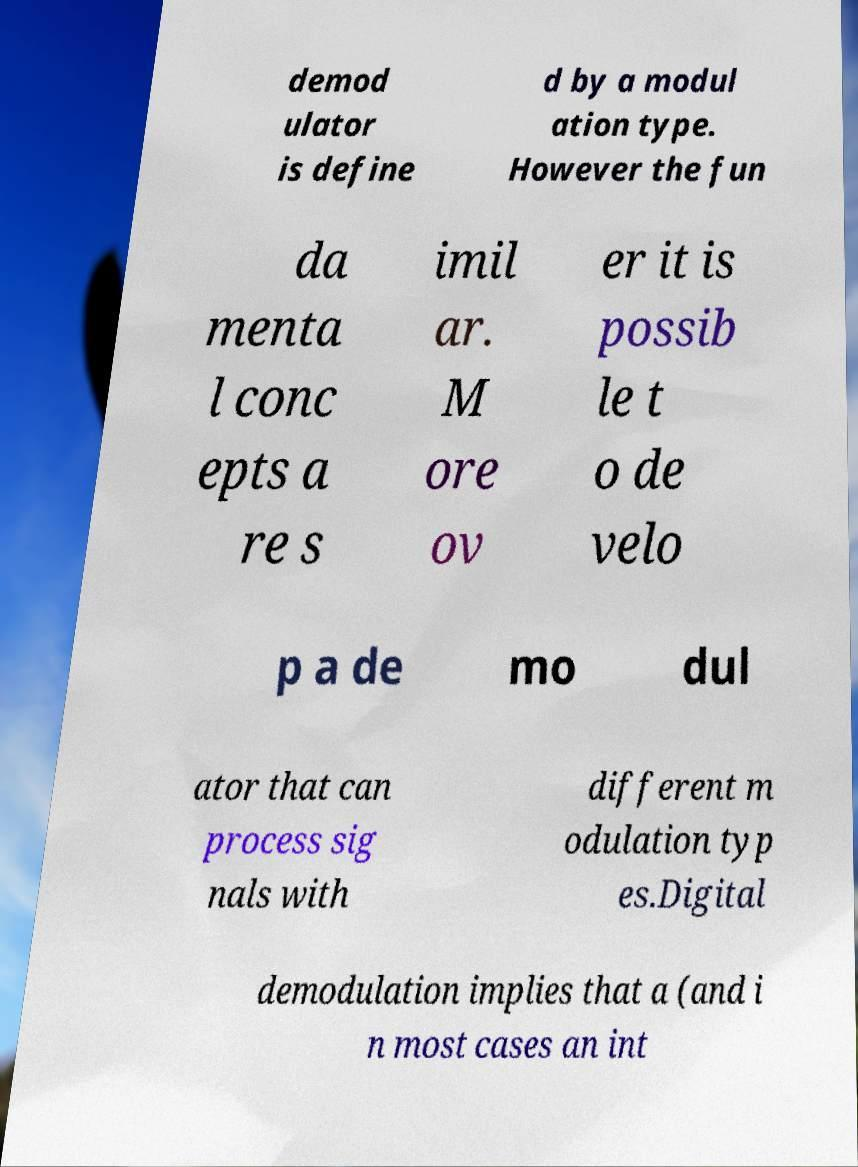There's text embedded in this image that I need extracted. Can you transcribe it verbatim? demod ulator is define d by a modul ation type. However the fun da menta l conc epts a re s imil ar. M ore ov er it is possib le t o de velo p a de mo dul ator that can process sig nals with different m odulation typ es.Digital demodulation implies that a (and i n most cases an int 